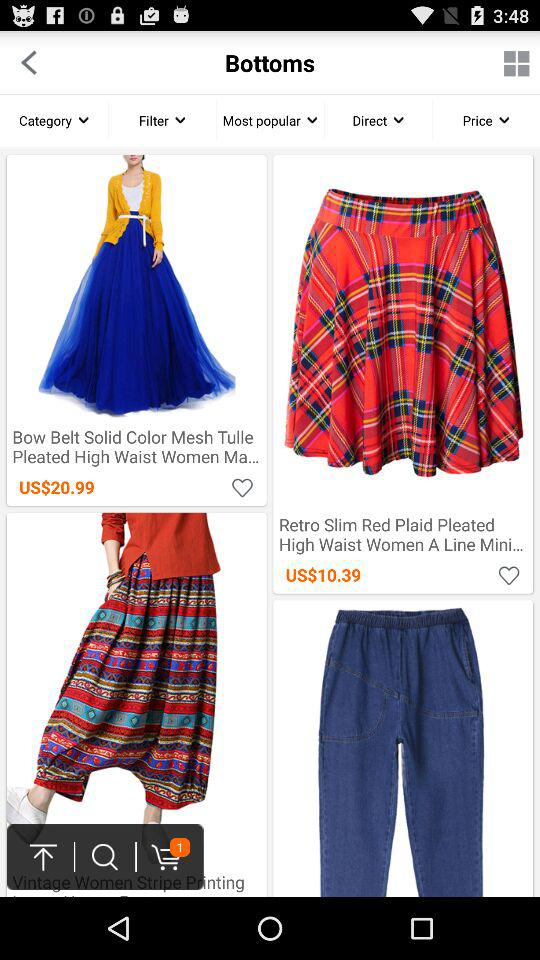Which items are listed in "Most popular"?
When the provided information is insufficient, respond with <no answer>. <no answer> 